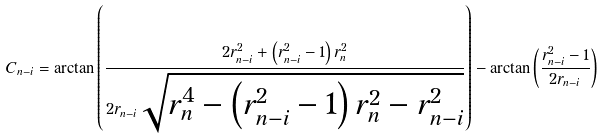<formula> <loc_0><loc_0><loc_500><loc_500>C _ { n - i } = \arctan { \left ( \frac { 2 r _ { n - i } ^ { 2 } + \left ( r _ { n - i } ^ { 2 } - 1 \right ) r _ { n } ^ { 2 } } { 2 r _ { n - i } \sqrt { r _ { n } ^ { 4 } - \left ( r _ { n - i } ^ { 2 } - 1 \right ) r _ { n } ^ { 2 } - r _ { n - i } ^ { 2 } } } \right ) } - \arctan { \left ( \frac { r _ { n - i } ^ { 2 } - 1 } { 2 r _ { n - i } } \right ) }</formula> 